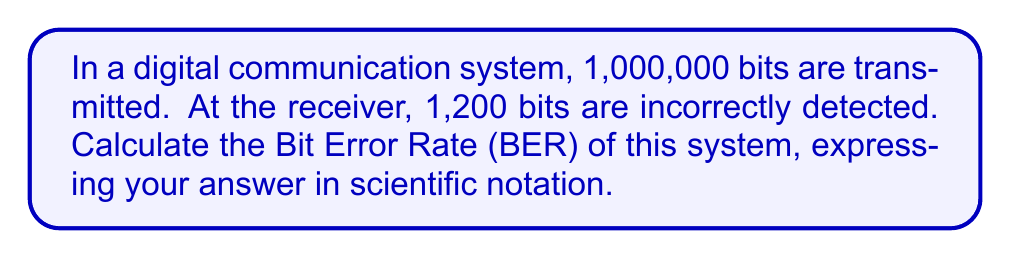Show me your answer to this math problem. To calculate the Bit Error Rate (BER), we need to follow these steps:

1. Identify the key components:
   - Total number of transmitted bits: $N_t = 1,000,000$
   - Number of incorrectly detected bits: $N_e = 1,200$

2. Apply the BER formula:
   $$ BER = \frac{\text{Number of error bits}}{\text{Total number of transmitted bits}} $$

3. Substitute the values:
   $$ BER = \frac{N_e}{N_t} = \frac{1,200}{1,000,000} $$

4. Perform the division:
   $$ BER = 0.0012 $$

5. Convert to scientific notation:
   $$ BER = 1.2 \times 10^{-3} $$

This result indicates that, on average, 1.2 out of every 1,000 bits are received incorrectly in this digital communication system.
Answer: $1.2 \times 10^{-3}$ 